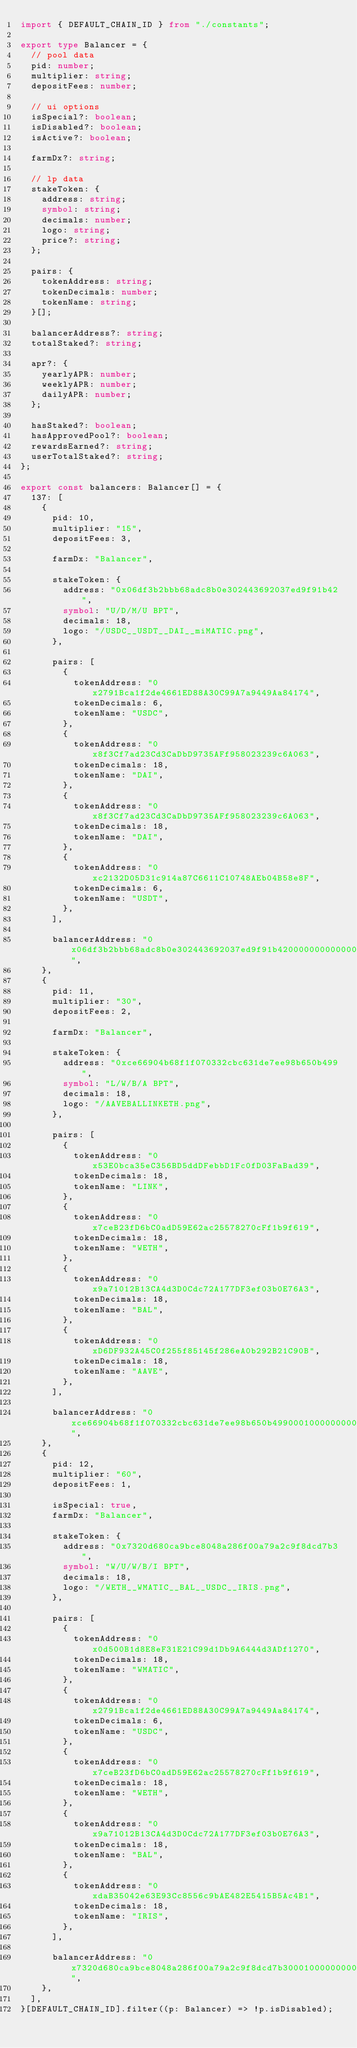<code> <loc_0><loc_0><loc_500><loc_500><_TypeScript_>import { DEFAULT_CHAIN_ID } from "./constants";

export type Balancer = {
  // pool data
  pid: number;
  multiplier: string;
  depositFees: number;

  // ui options
  isSpecial?: boolean;
  isDisabled?: boolean;
  isActive?: boolean;

  farmDx?: string;

  // lp data
  stakeToken: {
    address: string;
    symbol: string;
    decimals: number;
    logo: string;
    price?: string;
  };

  pairs: {
    tokenAddress: string;
    tokenDecimals: number;
    tokenName: string;
  }[];

  balancerAddress?: string;
  totalStaked?: string;

  apr?: {
    yearlyAPR: number;
    weeklyAPR: number;
    dailyAPR: number;
  };

  hasStaked?: boolean;
  hasApprovedPool?: boolean;
  rewardsEarned?: string;
  userTotalStaked?: string;
};

export const balancers: Balancer[] = {
  137: [
    {
      pid: 10,
      multiplier: "15",
      depositFees: 3,

      farmDx: "Balancer",

      stakeToken: {
        address: "0x06df3b2bbb68adc8b0e302443692037ed9f91b42",
        symbol: "U/D/M/U BPT",
        decimals: 18,
        logo: "/USDC__USDT__DAI__miMATIC.png",
      },

      pairs: [
        {
          tokenAddress: "0x2791Bca1f2de4661ED88A30C99A7a9449Aa84174",
          tokenDecimals: 6,
          tokenName: "USDC",
        },
        {
          tokenAddress: "0x8f3Cf7ad23Cd3CaDbD9735AFf958023239c6A063",
          tokenDecimals: 18,
          tokenName: "DAI",
        },
        {
          tokenAddress: "0x8f3Cf7ad23Cd3CaDbD9735AFf958023239c6A063",
          tokenDecimals: 18,
          tokenName: "DAI",
        },
        {
          tokenAddress: "0xc2132D05D31c914a87C6611C10748AEb04B58e8F",
          tokenDecimals: 6,
          tokenName: "USDT",
        },
      ],

      balancerAddress: "0x06df3b2bbb68adc8b0e302443692037ed9f91b42000000000000000000000012",
    },
    {
      pid: 11,
      multiplier: "30",
      depositFees: 2,

      farmDx: "Balancer",

      stakeToken: {
        address: "0xce66904b68f1f070332cbc631de7ee98b650b499",
        symbol: "L/W/B/A BPT",
        decimals: 18,
        logo: "/AAVEBALLINKETH.png",
      },

      pairs: [
        {
          tokenAddress: "0x53E0bca35eC356BD5ddDFebbD1Fc0fD03FaBad39",
          tokenDecimals: 18,
          tokenName: "LINK",
        },
        {
          tokenAddress: "0x7ceB23fD6bC0adD59E62ac25578270cFf1b9f619",
          tokenDecimals: 18,
          tokenName: "WETH",
        },
        {
          tokenAddress: "0x9a71012B13CA4d3D0Cdc72A177DF3ef03b0E76A3",
          tokenDecimals: 18,
          tokenName: "BAL",
        },
        {
          tokenAddress: "0xD6DF932A45C0f255f85145f286eA0b292B21C90B",
          tokenDecimals: 18,
          tokenName: "AAVE",
        },
      ],

      balancerAddress: "0xce66904b68f1f070332cbc631de7ee98b650b499000100000000000000000009",
    },
    {
      pid: 12,
      multiplier: "60",
      depositFees: 1,

      isSpecial: true,
      farmDx: "Balancer",

      stakeToken: {
        address: "0x7320d680ca9bce8048a286f00a79a2c9f8dcd7b3",
        symbol: "W/U/W/B/I BPT",
        decimals: 18,
        logo: "/WETH__WMATIC__BAL__USDC__IRIS.png",
      },

      pairs: [
        {
          tokenAddress: "0x0d500B1d8E8eF31E21C99d1Db9A6444d3ADf1270",
          tokenDecimals: 18,
          tokenName: "WMATIC",
        },
        {
          tokenAddress: "0x2791Bca1f2de4661ED88A30C99A7a9449Aa84174",
          tokenDecimals: 6,
          tokenName: "USDC",
        },
        {
          tokenAddress: "0x7ceB23fD6bC0adD59E62ac25578270cFf1b9f619",
          tokenDecimals: 18,
          tokenName: "WETH",
        },
        {
          tokenAddress: "0x9a71012B13CA4d3D0Cdc72A177DF3ef03b0E76A3",
          tokenDecimals: 18,
          tokenName: "BAL",
        },
        {
          tokenAddress: "0xdaB35042e63E93Cc8556c9bAE482E5415B5Ac4B1",
          tokenDecimals: 18,
          tokenName: "IRIS",
        },
      ],

      balancerAddress: "0x7320d680ca9bce8048a286f00a79a2c9f8dcd7b3000100000000000000000044",
    },
  ],
}[DEFAULT_CHAIN_ID].filter((p: Balancer) => !p.isDisabled);
</code> 